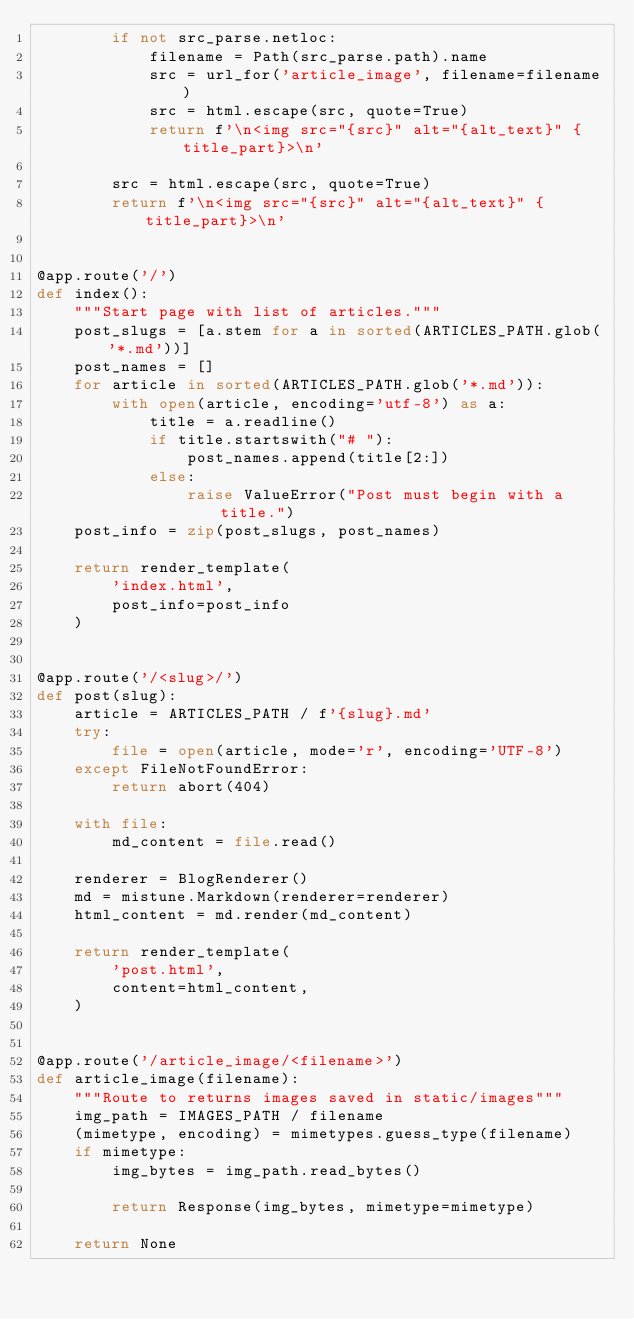<code> <loc_0><loc_0><loc_500><loc_500><_Python_>        if not src_parse.netloc:
            filename = Path(src_parse.path).name
            src = url_for('article_image', filename=filename)
            src = html.escape(src, quote=True)
            return f'\n<img src="{src}" alt="{alt_text}" {title_part}>\n'

        src = html.escape(src, quote=True)
        return f'\n<img src="{src}" alt="{alt_text}" {title_part}>\n'


@app.route('/')
def index():
    """Start page with list of articles."""
    post_slugs = [a.stem for a in sorted(ARTICLES_PATH.glob('*.md'))]
    post_names = []
    for article in sorted(ARTICLES_PATH.glob('*.md')):
        with open(article, encoding='utf-8') as a:
            title = a.readline()
            if title.startswith("# "):
                post_names.append(title[2:])
            else:
                raise ValueError("Post must begin with a title.")
    post_info = zip(post_slugs, post_names)

    return render_template(
        'index.html',
        post_info=post_info
    )


@app.route('/<slug>/')
def post(slug):
    article = ARTICLES_PATH / f'{slug}.md'
    try:
        file = open(article, mode='r', encoding='UTF-8')
    except FileNotFoundError:
        return abort(404)

    with file:
        md_content = file.read()

    renderer = BlogRenderer()
    md = mistune.Markdown(renderer=renderer)
    html_content = md.render(md_content)

    return render_template(
        'post.html',
        content=html_content,
    )


@app.route('/article_image/<filename>')
def article_image(filename):
    """Route to returns images saved in static/images"""
    img_path = IMAGES_PATH / filename
    (mimetype, encoding) = mimetypes.guess_type(filename)
    if mimetype:
        img_bytes = img_path.read_bytes()

        return Response(img_bytes, mimetype=mimetype)

    return None
</code> 